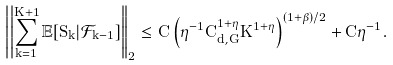<formula> <loc_0><loc_0><loc_500><loc_500>\left | \left | \sum _ { k = 1 } ^ { K + 1 } \mathbb { E } [ S _ { k } | \mathcal { F } _ { k - 1 } ] \right | \right | _ { 2 } \leq C \left ( \eta ^ { - 1 } C _ { d , G } ^ { 1 + \eta } K ^ { 1 + \eta } \right ) ^ { ( 1 + \beta ) / 2 } + C \eta ^ { - 1 } .</formula> 